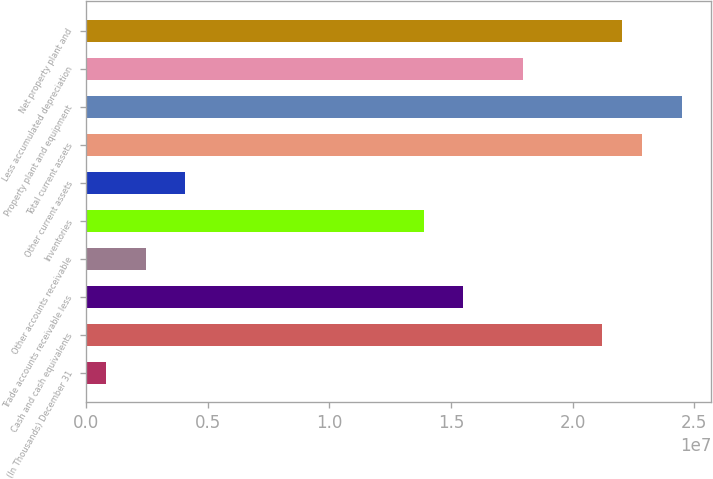<chart> <loc_0><loc_0><loc_500><loc_500><bar_chart><fcel>(In Thousands) December 31<fcel>Cash and cash equivalents<fcel>Trade accounts receivable less<fcel>Other accounts receivable<fcel>Inventories<fcel>Other current assets<fcel>Total current assets<fcel>Property plant and equipment<fcel>Less accumulated depreciation<fcel>Net property plant and<nl><fcel>817133<fcel>2.12173e+07<fcel>1.55053e+07<fcel>2.44915e+06<fcel>1.38733e+07<fcel>4.08117e+06<fcel>2.28494e+07<fcel>2.44814e+07<fcel>1.79533e+07<fcel>2.20333e+07<nl></chart> 